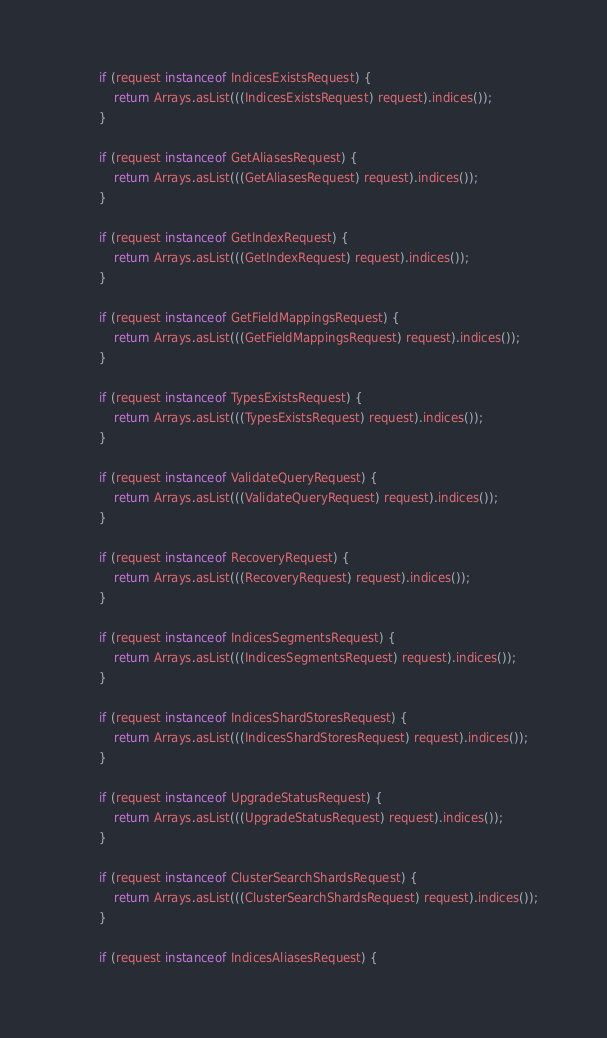Convert code to text. <code><loc_0><loc_0><loc_500><loc_500><_Java_>
		if (request instanceof IndicesExistsRequest) {
			return Arrays.asList(((IndicesExistsRequest) request).indices());
		}

		if (request instanceof GetAliasesRequest) {
			return Arrays.asList(((GetAliasesRequest) request).indices());
		}

		if (request instanceof GetIndexRequest) {
			return Arrays.asList(((GetIndexRequest) request).indices());
		}

		if (request instanceof GetFieldMappingsRequest) {
			return Arrays.asList(((GetFieldMappingsRequest) request).indices());
		}

		if (request instanceof TypesExistsRequest) {
			return Arrays.asList(((TypesExistsRequest) request).indices());
		}

		if (request instanceof ValidateQueryRequest) {
			return Arrays.asList(((ValidateQueryRequest) request).indices());
		}

		if (request instanceof RecoveryRequest) {
			return Arrays.asList(((RecoveryRequest) request).indices());
		}

		if (request instanceof IndicesSegmentsRequest) {
			return Arrays.asList(((IndicesSegmentsRequest) request).indices());
		}

		if (request instanceof IndicesShardStoresRequest) {
			return Arrays.asList(((IndicesShardStoresRequest) request).indices());
		}

		if (request instanceof UpgradeStatusRequest) {
			return Arrays.asList(((UpgradeStatusRequest) request).indices());
		}

		if (request instanceof ClusterSearchShardsRequest) {
			return Arrays.asList(((ClusterSearchShardsRequest) request).indices());
		}

		if (request instanceof IndicesAliasesRequest) {</code> 